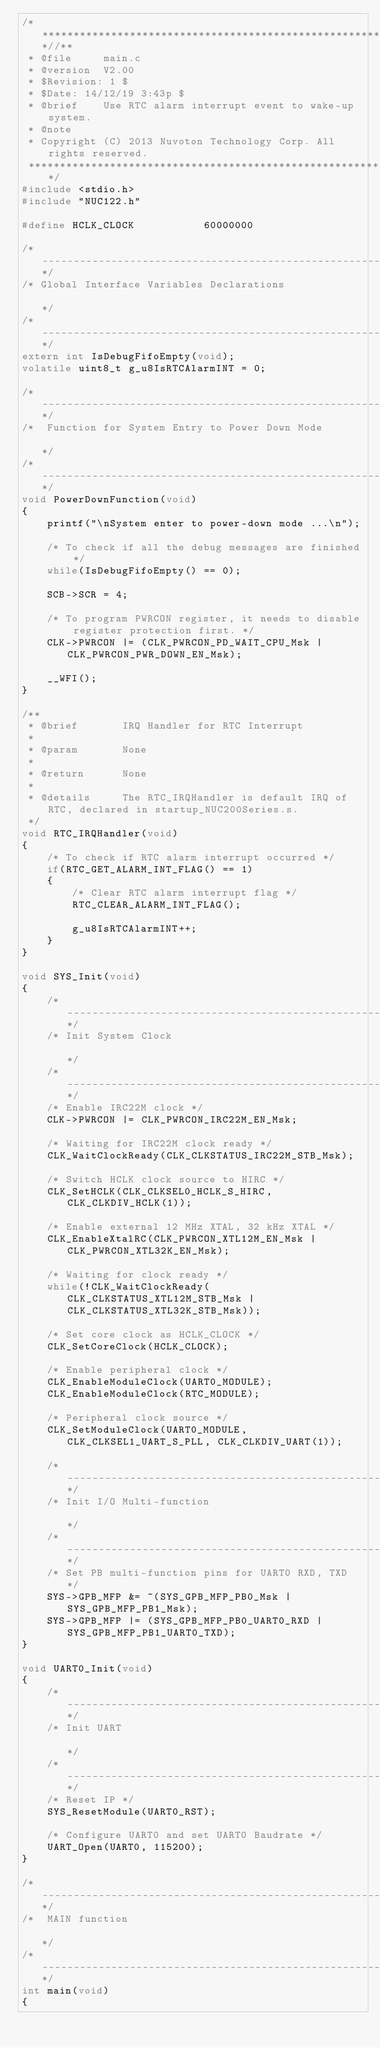Convert code to text. <code><loc_0><loc_0><loc_500><loc_500><_C_>/**************************************************************************//**
 * @file     main.c
 * @version  V2.00
 * $Revision: 1 $
 * $Date: 14/12/19 3:43p $
 * @brief    Use RTC alarm interrupt event to wake-up system.
 * @note
 * Copyright (C) 2013 Nuvoton Technology Corp. All rights reserved.
 ******************************************************************************/
#include <stdio.h>
#include "NUC122.h"

#define HCLK_CLOCK           60000000

/*---------------------------------------------------------------------------------------------------------*/
/* Global Interface Variables Declarations                                                                 */
/*---------------------------------------------------------------------------------------------------------*/
extern int IsDebugFifoEmpty(void);
volatile uint8_t g_u8IsRTCAlarmINT = 0;

/*---------------------------------------------------------------------------------------------------------*/
/*  Function for System Entry to Power Down Mode                                                           */
/*---------------------------------------------------------------------------------------------------------*/
void PowerDownFunction(void)
{
    printf("\nSystem enter to power-down mode ...\n");

    /* To check if all the debug messages are finished */
    while(IsDebugFifoEmpty() == 0);

    SCB->SCR = 4;

    /* To program PWRCON register, it needs to disable register protection first. */
    CLK->PWRCON |= (CLK_PWRCON_PD_WAIT_CPU_Msk | CLK_PWRCON_PWR_DOWN_EN_Msk);

    __WFI();
}

/**
 * @brief       IRQ Handler for RTC Interrupt
 *
 * @param       None
 *
 * @return      None
 *
 * @details     The RTC_IRQHandler is default IRQ of RTC, declared in startup_NUC200Series.s.
 */
void RTC_IRQHandler(void)
{
    /* To check if RTC alarm interrupt occurred */
    if(RTC_GET_ALARM_INT_FLAG() == 1)
    {
        /* Clear RTC alarm interrupt flag */
        RTC_CLEAR_ALARM_INT_FLAG();

        g_u8IsRTCAlarmINT++;
    }
}

void SYS_Init(void)
{
    /*---------------------------------------------------------------------------------------------------------*/
    /* Init System Clock                                                                                       */
    /*---------------------------------------------------------------------------------------------------------*/
    /* Enable IRC22M clock */
    CLK->PWRCON |= CLK_PWRCON_IRC22M_EN_Msk;

    /* Waiting for IRC22M clock ready */
    CLK_WaitClockReady(CLK_CLKSTATUS_IRC22M_STB_Msk);

    /* Switch HCLK clock source to HIRC */
    CLK_SetHCLK(CLK_CLKSEL0_HCLK_S_HIRC, CLK_CLKDIV_HCLK(1));

    /* Enable external 12 MHz XTAL, 32 kHz XTAL */
    CLK_EnableXtalRC(CLK_PWRCON_XTL12M_EN_Msk | CLK_PWRCON_XTL32K_EN_Msk);

    /* Waiting for clock ready */
    while(!CLK_WaitClockReady(CLK_CLKSTATUS_XTL12M_STB_Msk | CLK_CLKSTATUS_XTL32K_STB_Msk));

    /* Set core clock as HCLK_CLOCK */
    CLK_SetCoreClock(HCLK_CLOCK);

    /* Enable peripheral clock */
    CLK_EnableModuleClock(UART0_MODULE);
    CLK_EnableModuleClock(RTC_MODULE);

    /* Peripheral clock source */
    CLK_SetModuleClock(UART0_MODULE, CLK_CLKSEL1_UART_S_PLL, CLK_CLKDIV_UART(1));

    /*---------------------------------------------------------------------------------------------------------*/
    /* Init I/O Multi-function                                                                                 */
    /*---------------------------------------------------------------------------------------------------------*/
    /* Set PB multi-function pins for UART0 RXD, TXD */
    SYS->GPB_MFP &= ~(SYS_GPB_MFP_PB0_Msk | SYS_GPB_MFP_PB1_Msk);
    SYS->GPB_MFP |= (SYS_GPB_MFP_PB0_UART0_RXD | SYS_GPB_MFP_PB1_UART0_TXD);
}

void UART0_Init(void)
{
    /*---------------------------------------------------------------------------------------------------------*/
    /* Init UART                                                                                               */
    /*---------------------------------------------------------------------------------------------------------*/
    /* Reset IP */
    SYS_ResetModule(UART0_RST);

    /* Configure UART0 and set UART0 Baudrate */
    UART_Open(UART0, 115200);
}

/*---------------------------------------------------------------------------------------------------------*/
/*  MAIN function                                                                                          */
/*---------------------------------------------------------------------------------------------------------*/
int main(void)
{</code> 